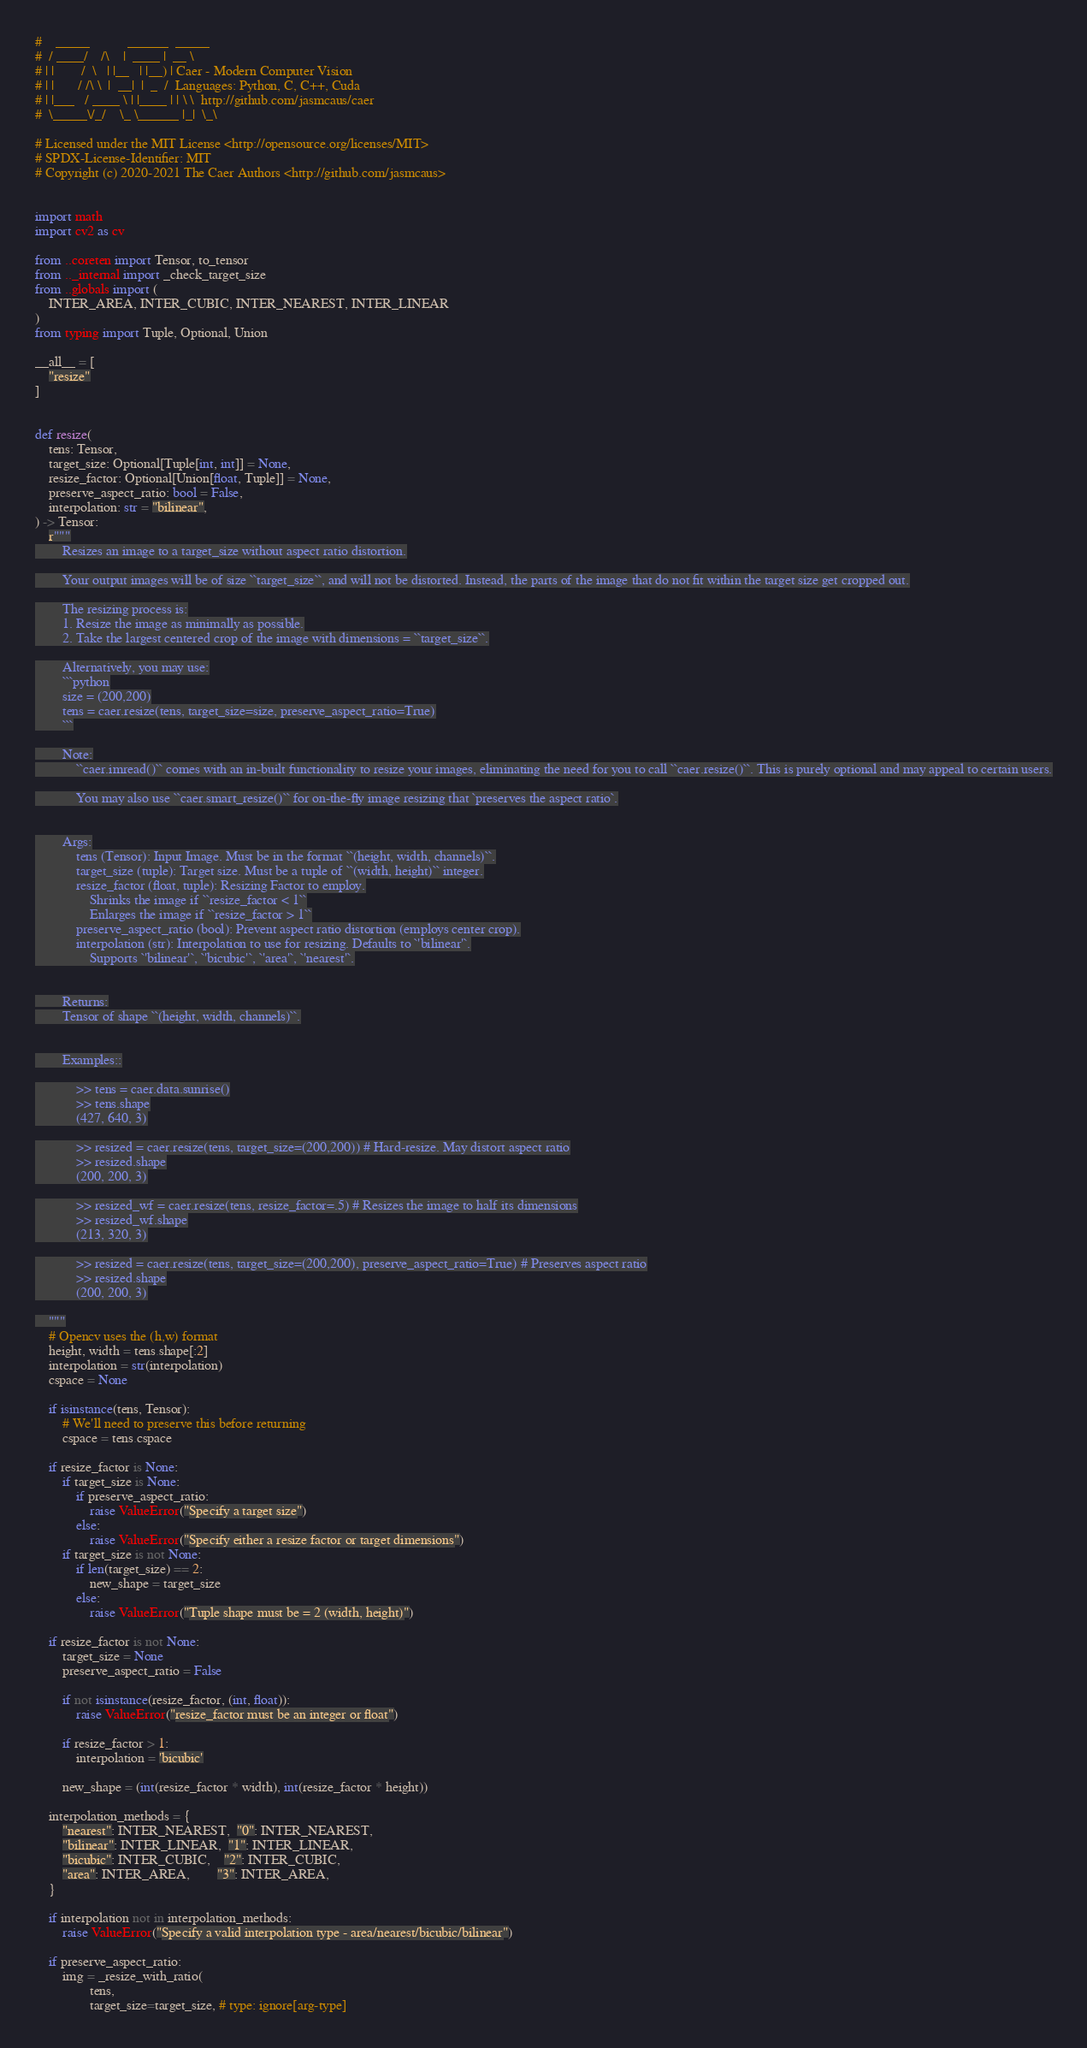<code> <loc_0><loc_0><loc_500><loc_500><_Python_>#    _____           ______  _____
#  / ____/    /\    |  ____ |  __ \
# | |        /  \   | |__   | |__) | Caer - Modern Computer Vision
# | |       / /\ \  |  __|  |  _  /  Languages: Python, C, C++, Cuda
# | |___   / ____ \ | |____ | | \ \  http://github.com/jasmcaus/caer
#  \_____\/_/    \_ \______ |_|  \_\

# Licensed under the MIT License <http://opensource.org/licenses/MIT>
# SPDX-License-Identifier: MIT
# Copyright (c) 2020-2021 The Caer Authors <http://github.com/jasmcaus>


import math
import cv2 as cv

from ..coreten import Tensor, to_tensor
from .._internal import _check_target_size
from ..globals import (
    INTER_AREA, INTER_CUBIC, INTER_NEAREST, INTER_LINEAR
)
from typing import Tuple, Optional, Union

__all__ = [
    "resize"
]


def resize(
    tens: Tensor,
    target_size: Optional[Tuple[int, int]] = None,
    resize_factor: Optional[Union[float, Tuple]] = None,
    preserve_aspect_ratio: bool = False,
    interpolation: str = "bilinear",
) -> Tensor:
    r"""
        Resizes an image to a target_size without aspect ratio distortion.

        Your output images will be of size ``target_size``, and will not be distorted. Instead, the parts of the image that do not fit within the target size get cropped out.

        The resizing process is:
        1. Resize the image as minimally as possible.
        2. Take the largest centered crop of the image with dimensions = ``target_size``.

        Alternatively, you may use:
        ```python
        size = (200,200)
        tens = caer.resize(tens, target_size=size, preserve_aspect_ratio=True)
        ```

        Note:
            ``caer.imread()`` comes with an in-built functionality to resize your images, eliminating the need for you to call ``caer.resize()``. This is purely optional and may appeal to certain users.

            You may also use ``caer.smart_resize()`` for on-the-fly image resizing that `preserves the aspect ratio`.


        Args:
            tens (Tensor): Input Image. Must be in the format ``(height, width, channels)``.
            target_size (tuple): Target size. Must be a tuple of ``(width, height)`` integer.
            resize_factor (float, tuple): Resizing Factor to employ.
                Shrinks the image if ``resize_factor < 1``
                Enlarges the image if ``resize_factor > 1``
            preserve_aspect_ratio (bool): Prevent aspect ratio distortion (employs center crop).
            interpolation (str): Interpolation to use for resizing. Defaults to `'bilinear'`.
                Supports `'bilinear'`, `'bicubic'`, `'area'`, `'nearest'`.


        Returns:
        Tensor of shape ``(height, width, channels)``.


        Examples::

            >> tens = caer.data.sunrise()
            >> tens.shape
            (427, 640, 3)

            >> resized = caer.resize(tens, target_size=(200,200)) # Hard-resize. May distort aspect ratio
            >> resized.shape
            (200, 200, 3)

            >> resized_wf = caer.resize(tens, resize_factor=.5) # Resizes the image to half its dimensions
            >> resized_wf.shape
            (213, 320, 3)

            >> resized = caer.resize(tens, target_size=(200,200), preserve_aspect_ratio=True) # Preserves aspect ratio
            >> resized.shape
            (200, 200, 3)

    """
    # Opencv uses the (h,w) format
    height, width = tens.shape[:2]
    interpolation = str(interpolation)
    cspace = None

    if isinstance(tens, Tensor):
        # We'll need to preserve this before returning
        cspace = tens.cspace

    if resize_factor is None:
        if target_size is None:
            if preserve_aspect_ratio:
                raise ValueError("Specify a target size")
            else:
                raise ValueError("Specify either a resize factor or target dimensions")
        if target_size is not None:
            if len(target_size) == 2:
                new_shape = target_size
            else:
                raise ValueError("Tuple shape must be = 2 (width, height)")

    if resize_factor is not None:
        target_size = None
        preserve_aspect_ratio = False

        if not isinstance(resize_factor, (int, float)):
            raise ValueError("resize_factor must be an integer or float")

        if resize_factor > 1:
            interpolation = 'bicubic'

        new_shape = (int(resize_factor * width), int(resize_factor * height))

    interpolation_methods = {
        "nearest": INTER_NEAREST,  "0": INTER_NEAREST,
        "bilinear": INTER_LINEAR,  "1": INTER_LINEAR,
        "bicubic": INTER_CUBIC,    "2": INTER_CUBIC,
        "area": INTER_AREA,        "3": INTER_AREA,
    }

    if interpolation not in interpolation_methods:
        raise ValueError("Specify a valid interpolation type - area/nearest/bicubic/bilinear")

    if preserve_aspect_ratio:
        img = _resize_with_ratio(
                tens,
                target_size=target_size, # type: ignore[arg-type]</code> 